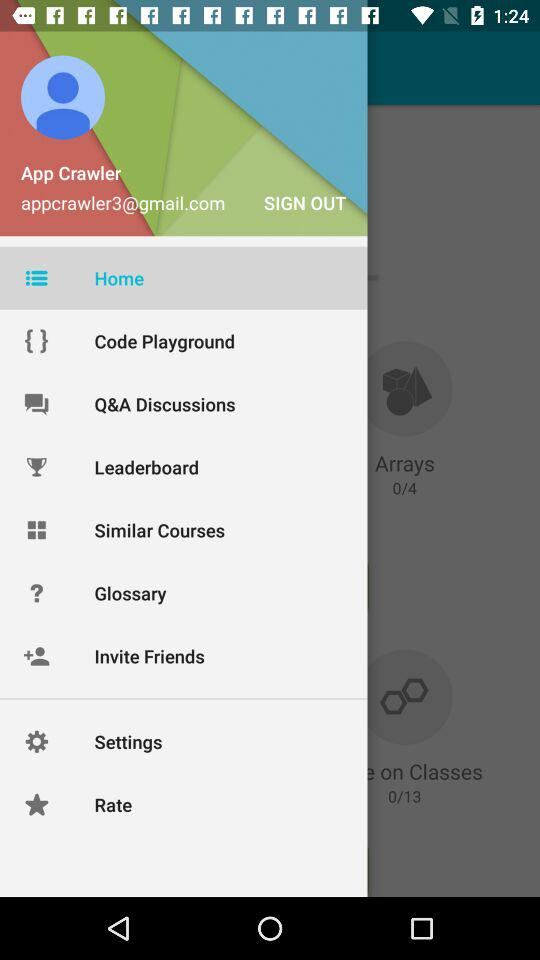What is the user name? The user name is App Crawler. 